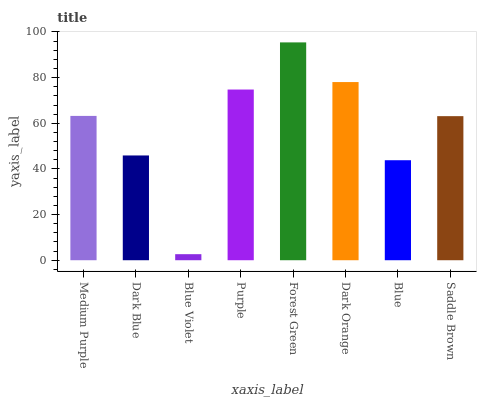Is Blue Violet the minimum?
Answer yes or no. Yes. Is Forest Green the maximum?
Answer yes or no. Yes. Is Dark Blue the minimum?
Answer yes or no. No. Is Dark Blue the maximum?
Answer yes or no. No. Is Medium Purple greater than Dark Blue?
Answer yes or no. Yes. Is Dark Blue less than Medium Purple?
Answer yes or no. Yes. Is Dark Blue greater than Medium Purple?
Answer yes or no. No. Is Medium Purple less than Dark Blue?
Answer yes or no. No. Is Medium Purple the high median?
Answer yes or no. Yes. Is Saddle Brown the low median?
Answer yes or no. Yes. Is Purple the high median?
Answer yes or no. No. Is Purple the low median?
Answer yes or no. No. 